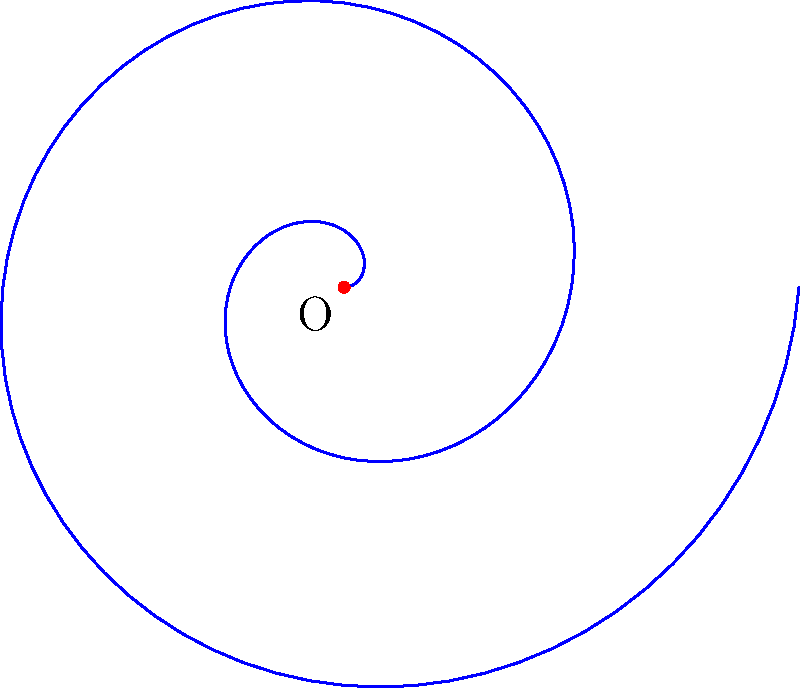In ancient scroll designs, spiral patterns were often used for decorative purposes. The image shows an Archimedean spiral, which is described by the equation $r = a\theta$, where $r$ is the distance from the center, $\theta$ is the angle in radians, and $a$ is a constant. If the spiral makes two complete revolutions and the distance OA is 4 units, what is the value of the constant $a$? To solve this problem, let's follow these steps:

1) An Archimedean spiral is defined by the equation $r = a\theta$, where $a$ is the constant we need to find.

2) We're told that the spiral makes two complete revolutions. In radians, two revolutions is equal to $4\pi$ radians:
   $\theta = 4\pi$

3) We're also told that the distance OA (which is the final $r$ value) is 4 units:
   $r = 4$

4) Now we can substitute these values into the equation $r = a\theta$:
   $4 = a(4\pi)$

5) Solving for $a$:
   $a = \frac{4}{4\pi} = \frac{1}{\pi}$

Therefore, the constant $a$ in the equation of this Archimedean spiral is $\frac{1}{\pi}$.
Answer: $\frac{1}{\pi}$ 